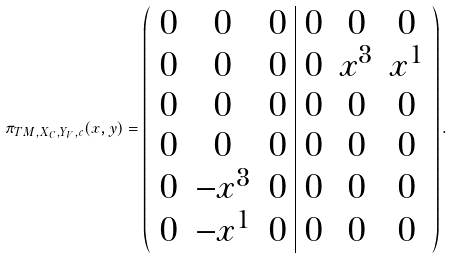<formula> <loc_0><loc_0><loc_500><loc_500>\pi _ { T M , X _ { C } , Y _ { V } , c } ( { x } , { y } ) = \left ( \begin{array} { c c c | c c c } 0 & 0 & 0 & 0 & 0 & 0 \\ 0 & 0 & 0 & 0 & x ^ { 3 } & x ^ { 1 } \\ 0 & 0 & 0 & 0 & 0 & 0 \\ 0 & 0 & 0 & 0 & 0 & 0 \\ 0 & - x ^ { 3 } & 0 & 0 & 0 & 0 \\ 0 & - x ^ { 1 } & 0 & 0 & 0 & 0 \\ \end{array} \right ) .</formula> 